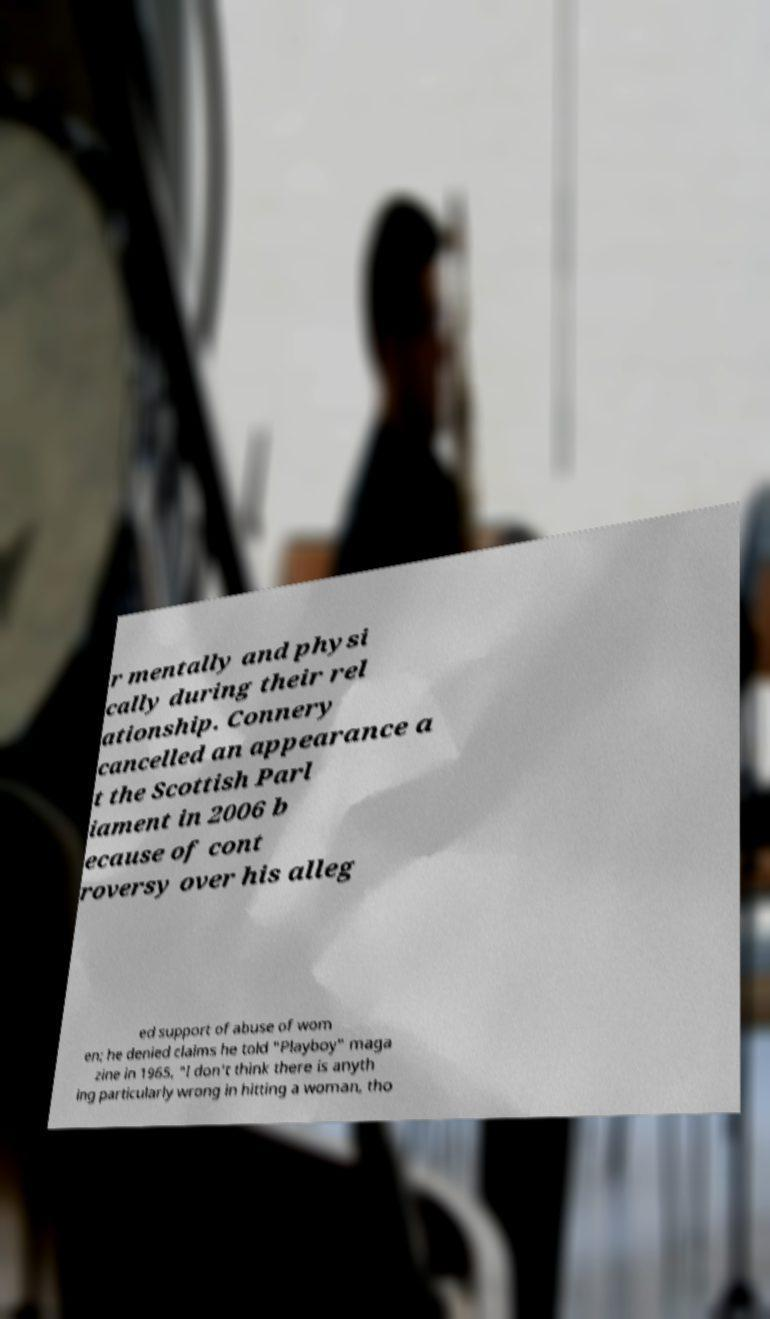Could you assist in decoding the text presented in this image and type it out clearly? r mentally and physi cally during their rel ationship. Connery cancelled an appearance a t the Scottish Parl iament in 2006 b ecause of cont roversy over his alleg ed support of abuse of wom en; he denied claims he told "Playboy" maga zine in 1965, "I don't think there is anyth ing particularly wrong in hitting a woman, tho 